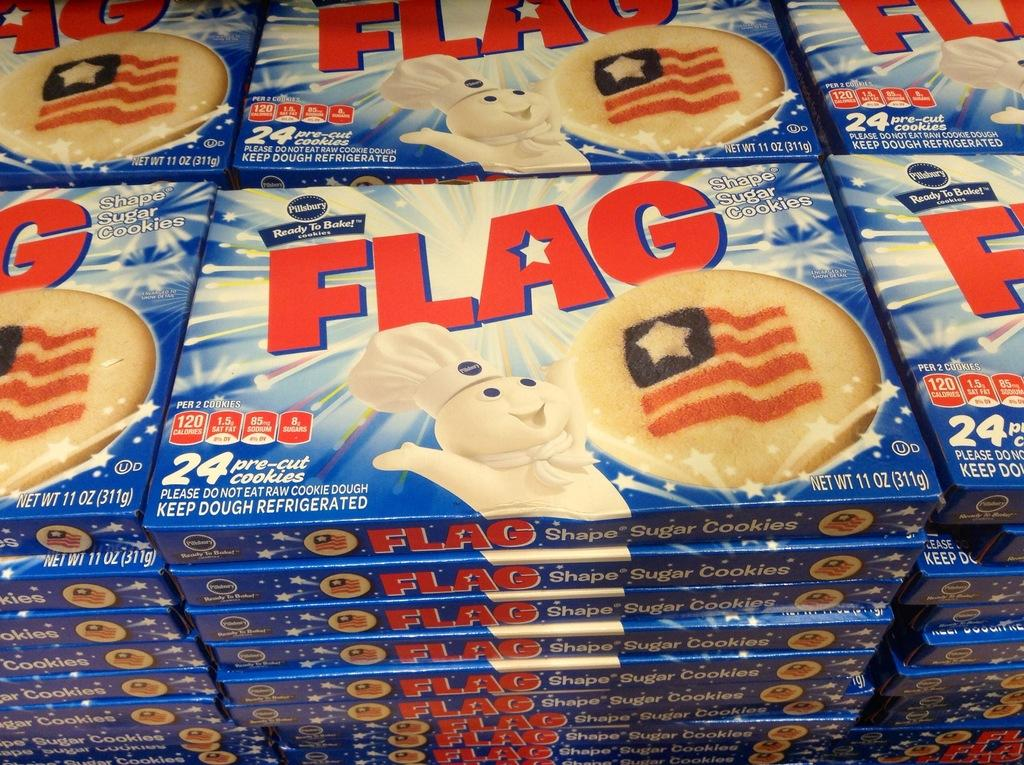What objects are present in the image? There are boxes in the image. What color are the boxes? The boxes are blue in color. What is written or printed on the boxes? There is text on the boxes. What images can be seen on the boxes? There are images of a toy and a biscuit on the boxes. Where is the calendar located in the image? There is no calendar present in the image. What type of guide is shown in the image? There is no guide present in the image. 